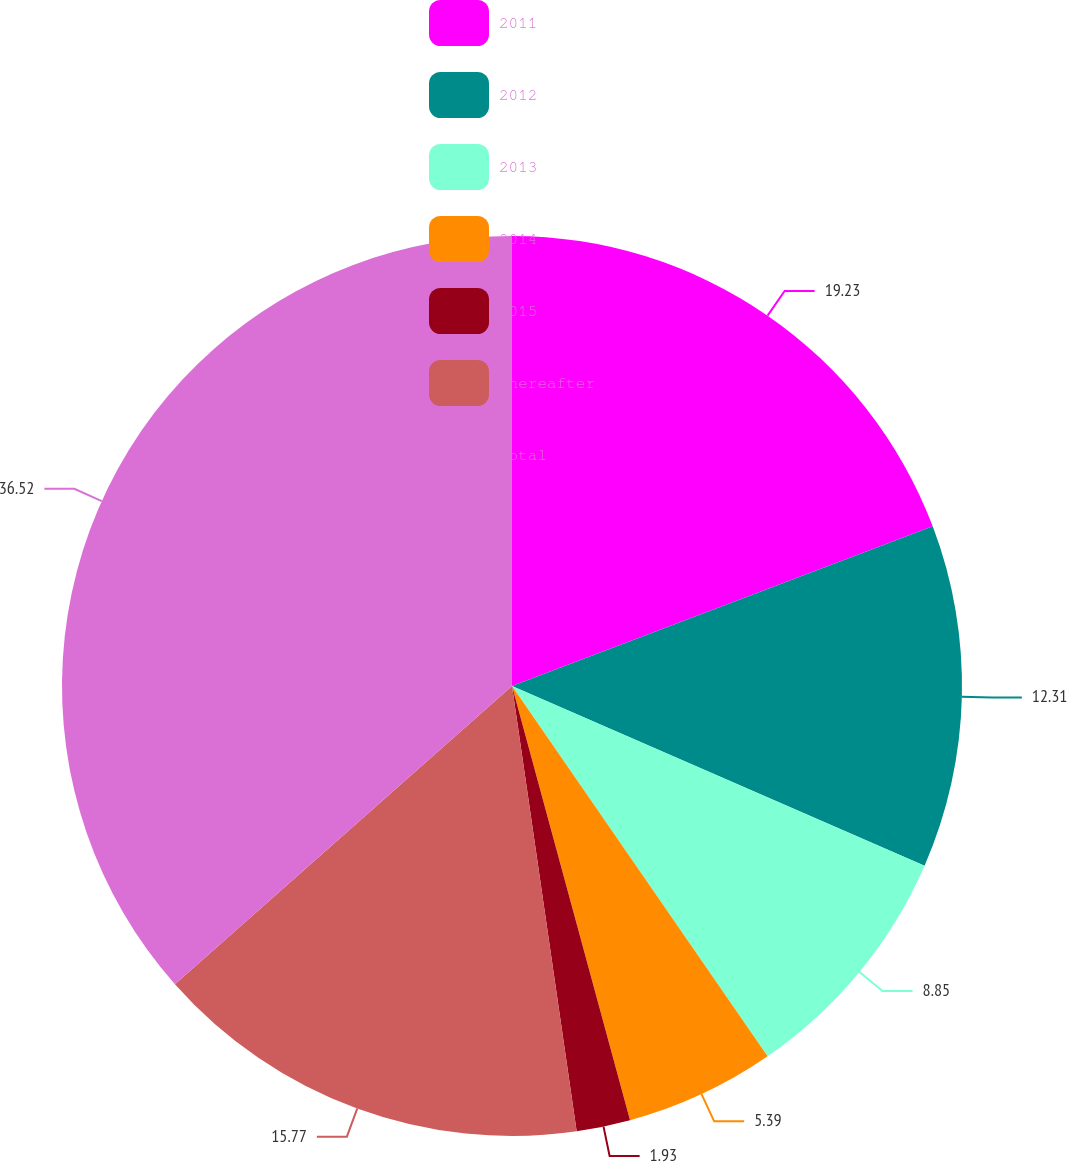Convert chart to OTSL. <chart><loc_0><loc_0><loc_500><loc_500><pie_chart><fcel>2011<fcel>2012<fcel>2013<fcel>2014<fcel>2015<fcel>Thereafter<fcel>Total<nl><fcel>19.23%<fcel>12.31%<fcel>8.85%<fcel>5.39%<fcel>1.93%<fcel>15.77%<fcel>36.53%<nl></chart> 